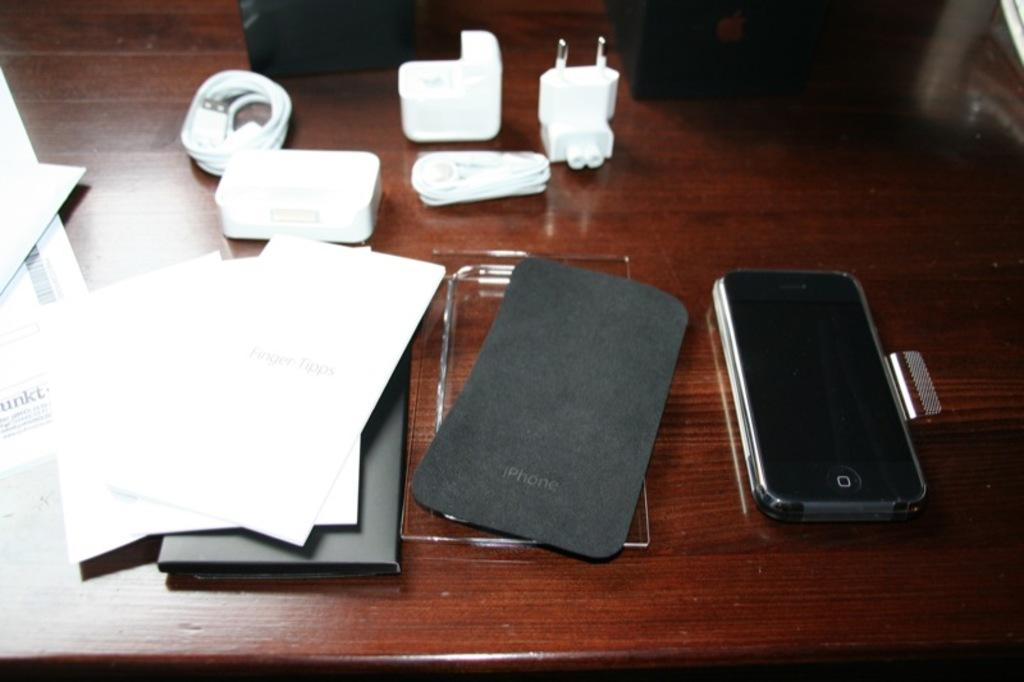Provide a one-sentence caption for the provided image. A messy desktop with a corner of paper that reads unkt. 